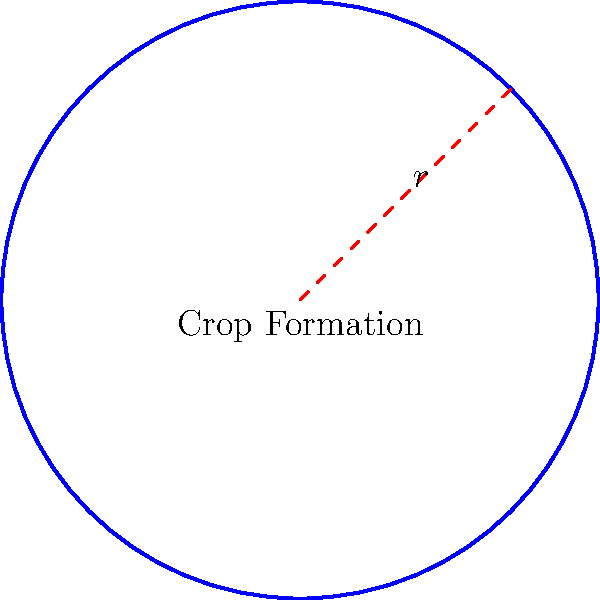In a remote field, an alien crop formation has been discovered in the shape of a perfect circle. As a sci-fi enthusiast investigating extraterrestrial phenomena, you've determined that the radius of this formation is 50 meters. What is the perimeter of this mysterious crop circle? To find the perimeter of a circular alien crop formation, we need to use the formula for the circumference of a circle. The steps are as follows:

1. Recall the formula for the circumference of a circle:
   $$C = 2\pi r$$
   where $C$ is the circumference (perimeter) and $r$ is the radius.

2. We are given that the radius $r = 50$ meters.

3. Substitute the value into the formula:
   $$C = 2\pi (50)$$

4. Simplify:
   $$C = 100\pi \text{ meters}$$

5. If we need a decimal approximation, we can use $\pi \approx 3.14159$:
   $$C \approx 100 \times 3.14159 \approx 314.159 \text{ meters}$$

The perimeter of the alien crop formation is $100\pi$ meters, or approximately 314.159 meters.
Answer: $100\pi$ meters 